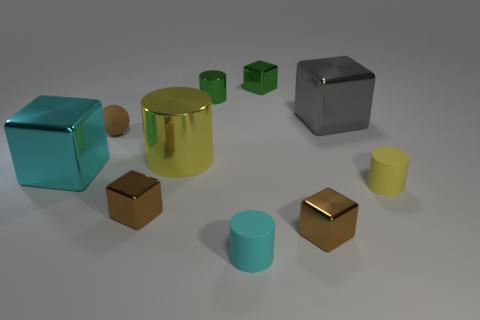What number of cyan blocks are the same material as the gray cube?
Offer a terse response. 1. There is a small shiny block that is on the left side of the small green block behind the shiny cylinder behind the big gray metallic object; what is its color?
Your response must be concise. Brown. Do the brown matte thing and the green cylinder have the same size?
Make the answer very short. Yes. Is there any other thing that has the same shape as the brown rubber object?
Your answer should be very brief. No. What number of objects are big metal objects that are in front of the small matte ball or metal objects?
Your response must be concise. 7. Does the cyan metal object have the same shape as the gray metallic object?
Your answer should be very brief. Yes. How many other objects are there of the same size as the yellow shiny cylinder?
Keep it short and to the point. 2. What is the color of the small shiny cylinder?
Your answer should be compact. Green. How many large objects are brown spheres or red shiny objects?
Provide a short and direct response. 0. There is a matte cylinder that is to the left of the gray shiny object; is it the same size as the cyan block that is behind the small cyan thing?
Provide a short and direct response. No. 